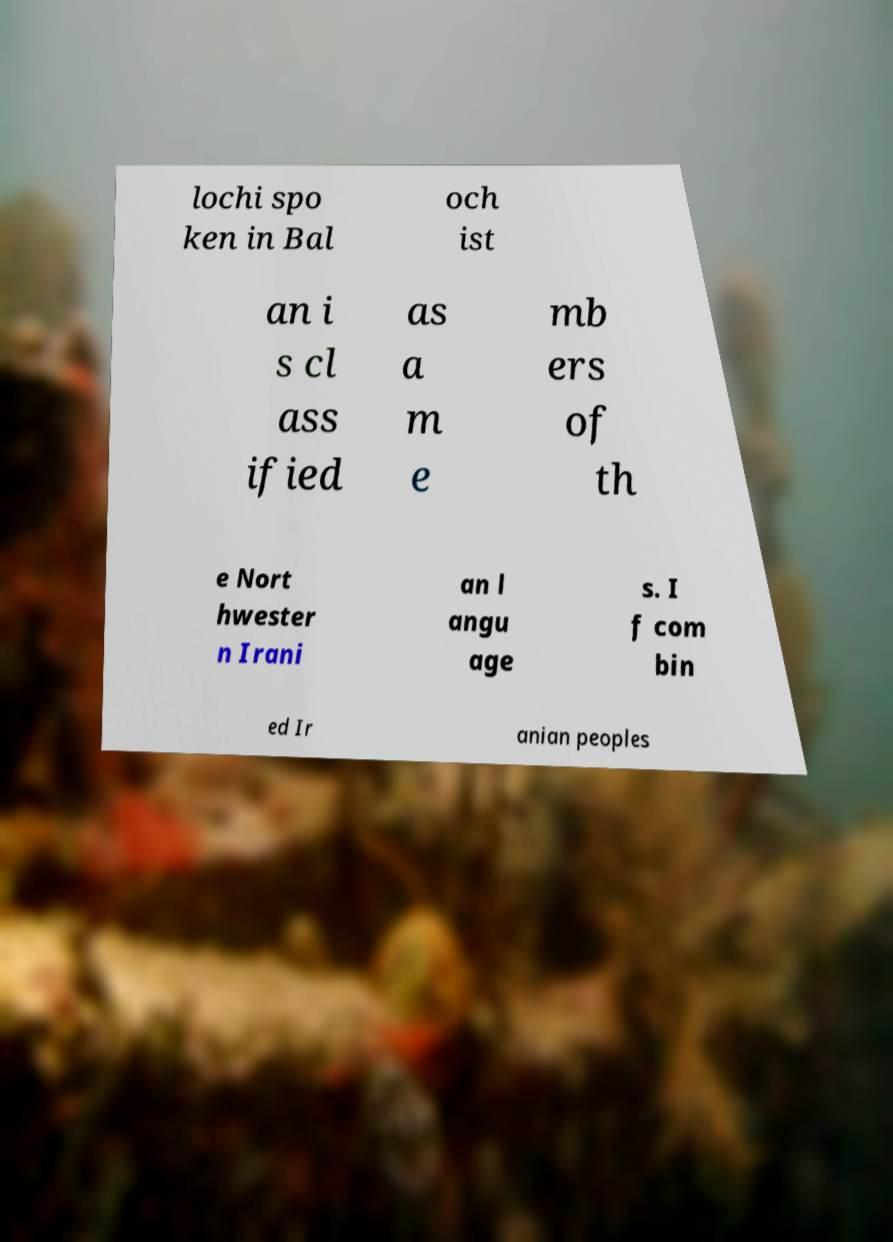Please read and relay the text visible in this image. What does it say? lochi spo ken in Bal och ist an i s cl ass ified as a m e mb ers of th e Nort hwester n Irani an l angu age s. I f com bin ed Ir anian peoples 